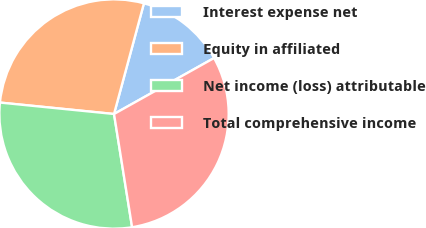Convert chart to OTSL. <chart><loc_0><loc_0><loc_500><loc_500><pie_chart><fcel>Interest expense net<fcel>Equity in affiliated<fcel>Net income (loss) attributable<fcel>Total comprehensive income<nl><fcel>12.68%<fcel>27.61%<fcel>29.11%<fcel>30.6%<nl></chart> 